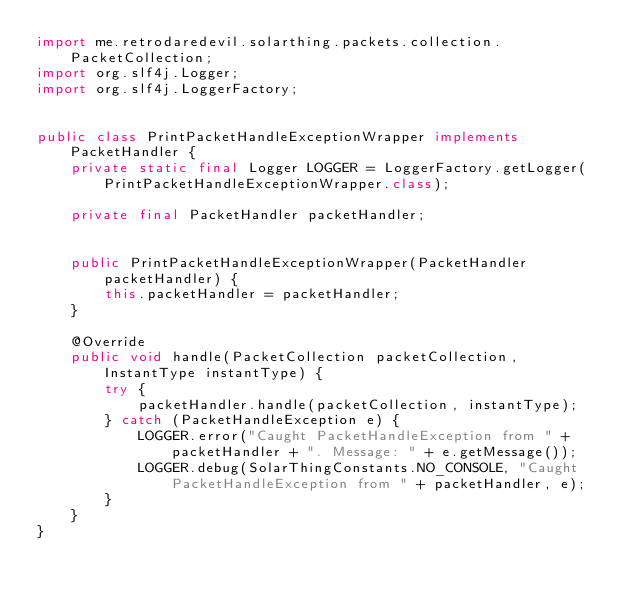<code> <loc_0><loc_0><loc_500><loc_500><_Java_>import me.retrodaredevil.solarthing.packets.collection.PacketCollection;
import org.slf4j.Logger;
import org.slf4j.LoggerFactory;


public class PrintPacketHandleExceptionWrapper implements PacketHandler {
	private static final Logger LOGGER = LoggerFactory.getLogger(PrintPacketHandleExceptionWrapper.class);

	private final PacketHandler packetHandler;


	public PrintPacketHandleExceptionWrapper(PacketHandler packetHandler) {
		this.packetHandler = packetHandler;
	}

	@Override
	public void handle(PacketCollection packetCollection, InstantType instantType) {
		try {
			packetHandler.handle(packetCollection, instantType);
		} catch (PacketHandleException e) {
			LOGGER.error("Caught PacketHandleException from " + packetHandler + ". Message: " + e.getMessage());
			LOGGER.debug(SolarThingConstants.NO_CONSOLE, "Caught PacketHandleException from " + packetHandler, e);
		}
	}
}
</code> 